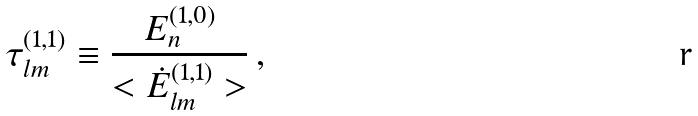Convert formula to latex. <formula><loc_0><loc_0><loc_500><loc_500>\tau ^ { ( 1 , 1 ) } _ { l m } \equiv \frac { E ^ { ( 1 , 0 ) } _ { n } } { < \dot { E } ^ { ( 1 , 1 ) } _ { l m } > } \, ,</formula> 